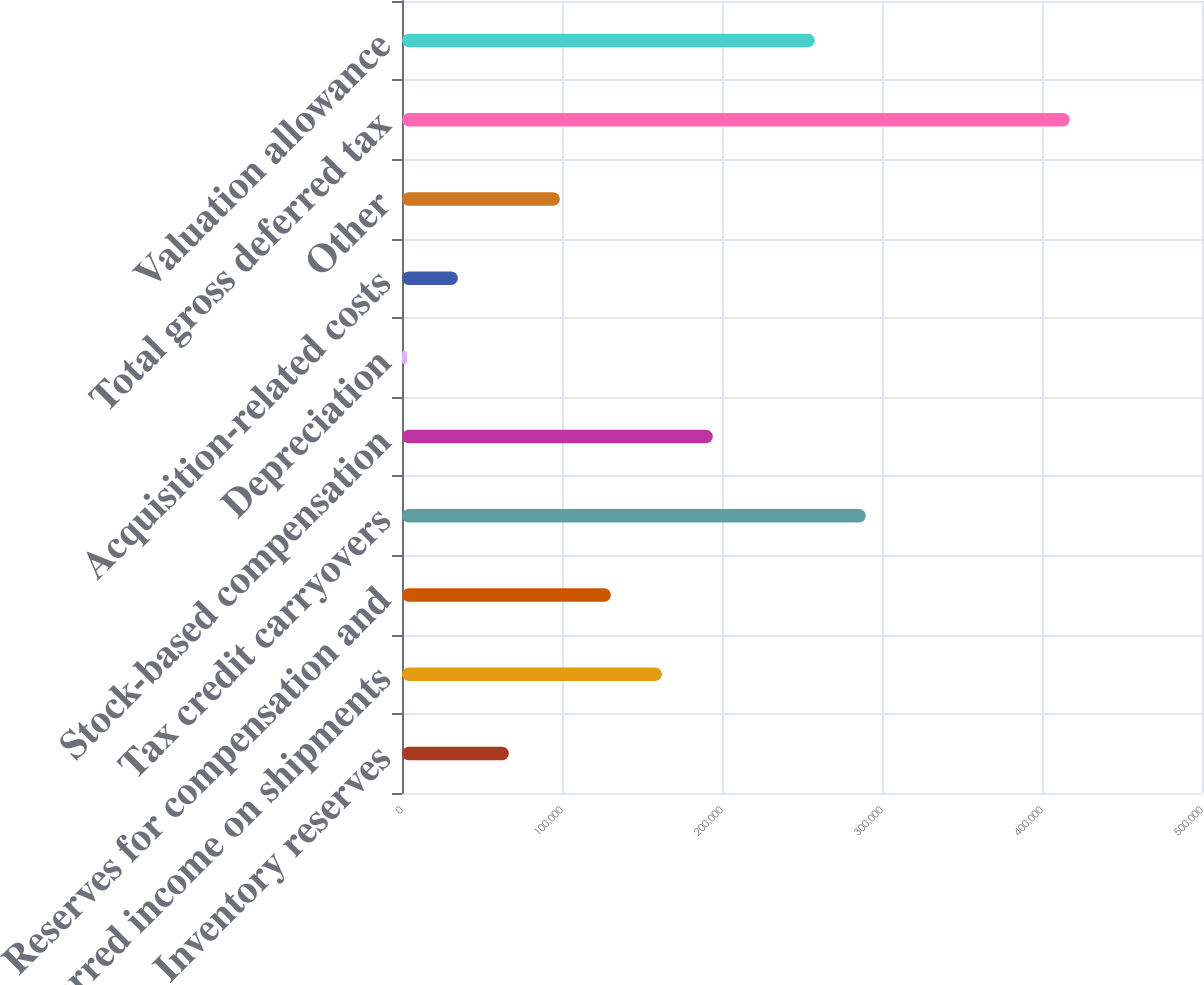Convert chart to OTSL. <chart><loc_0><loc_0><loc_500><loc_500><bar_chart><fcel>Inventory reserves<fcel>Deferred income on shipments<fcel>Reserves for compensation and<fcel>Tax credit carryovers<fcel>Stock-based compensation<fcel>Depreciation<fcel>Acquisition-related costs<fcel>Other<fcel>Total gross deferred tax<fcel>Valuation allowance<nl><fcel>66814.8<fcel>162420<fcel>130552<fcel>289894<fcel>194288<fcel>3078<fcel>34946.4<fcel>98683.2<fcel>417367<fcel>258025<nl></chart> 